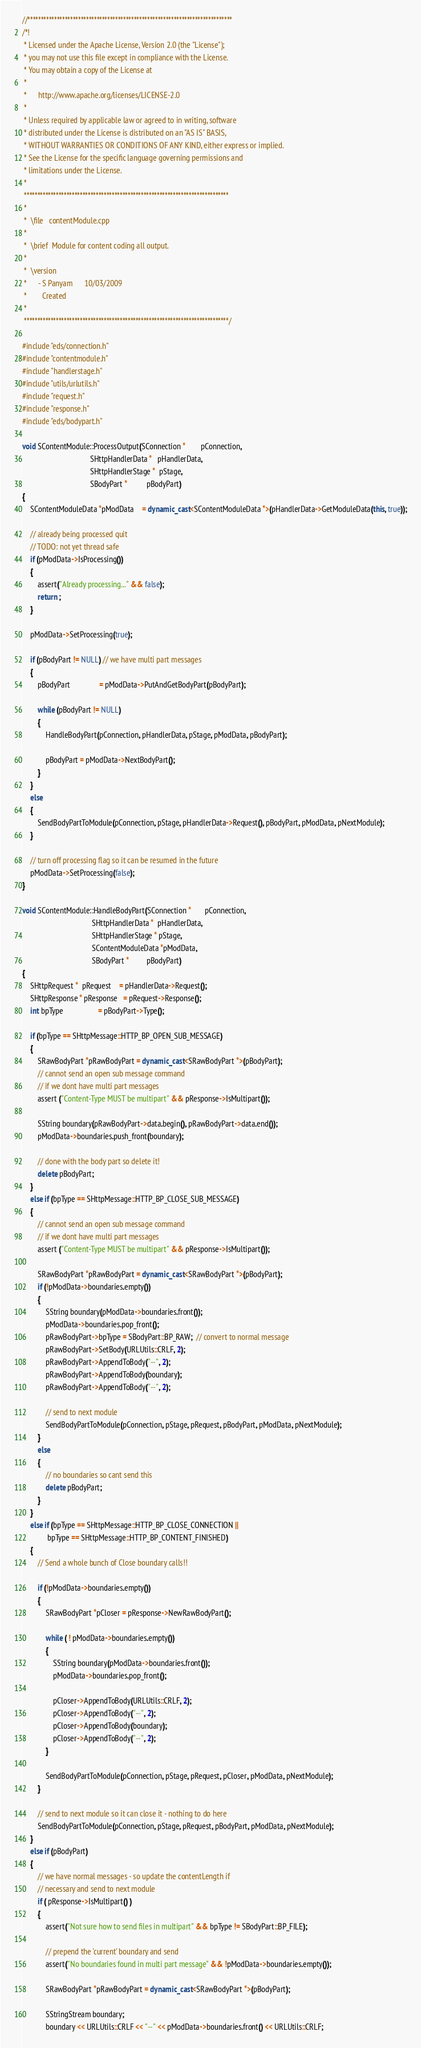Convert code to text. <code><loc_0><loc_0><loc_500><loc_500><_C++_>//*****************************************************************************
/*!
 * Licensed under the Apache License, Version 2.0 (the "License");
 * you may not use this file except in compliance with the License.
 * You may obtain a copy of the License at
 *
 *      http://www.apache.org/licenses/LICENSE-2.0
 *
 * Unless required by applicable law or agreed to in writing, software
 * distributed under the License is distributed on an "AS IS" BASIS,
 * WITHOUT WARRANTIES OR CONDITIONS OF ANY KIND, either express or implied.
 * See the License for the specific language governing permissions and
 * limitations under the License.
 *
 *****************************************************************************
 *
 *  \file   contentModule.cpp
 *
 *  \brief  Module for content coding all output.
 *
 *  \version
 *      - S Panyam      10/03/2009
 *        Created
 *
 *****************************************************************************/

#include "eds/connection.h"
#include "contentmodule.h"
#include "handlerstage.h"
#include "utils/urlutils.h"
#include "request.h"
#include "response.h"
#include "eds/bodypart.h"

void SContentModule::ProcessOutput(SConnection *        pConnection,
                                   SHttpHandlerData *   pHandlerData,
                                   SHttpHandlerStage *  pStage,
                                   SBodyPart *          pBodyPart)
{
    SContentModuleData *pModData    = dynamic_cast<SContentModuleData *>(pHandlerData->GetModuleData(this, true));

    // already being processed quit
    // TODO: not yet thread safe
    if (pModData->IsProcessing())
    {
        assert("Already processing..." && false);
        return ;
    }

    pModData->SetProcessing(true);

    if (pBodyPart != NULL) // we have multi part messages
    {
        pBodyPart               = pModData->PutAndGetBodyPart(pBodyPart);

        while (pBodyPart != NULL)
        {
            HandleBodyPart(pConnection, pHandlerData, pStage, pModData, pBodyPart);

            pBodyPart = pModData->NextBodyPart();
        }
    }
    else
    {
        SendBodyPartToModule(pConnection, pStage, pHandlerData->Request(), pBodyPart, pModData, pNextModule);
    }

    // turn off processing flag so it can be resumed in the future
    pModData->SetProcessing(false);
}

void SContentModule::HandleBodyPart(SConnection *       pConnection,
                                    SHttpHandlerData *  pHandlerData, 
                                    SHttpHandlerStage * pStage,
                                    SContentModuleData *pModData,
                                    SBodyPart *         pBodyPart)
{
    SHttpRequest *  pRequest    = pHandlerData->Request();
    SHttpResponse * pResponse   = pRequest->Response();
    int bpType                  = pBodyPart->Type();

    if (bpType == SHttpMessage::HTTP_BP_OPEN_SUB_MESSAGE)
    {
        SRawBodyPart *pRawBodyPart = dynamic_cast<SRawBodyPart *>(pBodyPart);
        // cannot send an open sub message command 
        // if we dont have multi part messages
        assert ("Content-Type MUST be multipart" && pResponse->IsMultipart());

        SString boundary(pRawBodyPart->data.begin(), pRawBodyPart->data.end());
        pModData->boundaries.push_front(boundary);

        // done with the body part so delete it!
        delete pBodyPart;
    }
    else if (bpType == SHttpMessage::HTTP_BP_CLOSE_SUB_MESSAGE)
    {
        // cannot send an open sub message command 
        // if we dont have multi part messages
        assert ("Content-Type MUST be multipart" && pResponse->IsMultipart());

        SRawBodyPart *pRawBodyPart = dynamic_cast<SRawBodyPart *>(pBodyPart);
        if (!pModData->boundaries.empty())
        {
            SString boundary(pModData->boundaries.front());
            pModData->boundaries.pop_front();
            pRawBodyPart->bpType = SBodyPart::BP_RAW;  // convert to normal message
            pRawBodyPart->SetBody(URLUtils::CRLF, 2);
            pRawBodyPart->AppendToBody("--", 2);
            pRawBodyPart->AppendToBody(boundary);
            pRawBodyPart->AppendToBody("--", 2);

            // send to next module
            SendBodyPartToModule(pConnection, pStage, pRequest, pBodyPart, pModData, pNextModule);
        }
        else
        {
            // no boundaries so cant send this
            delete pBodyPart;
        }
    }
    else if (bpType == SHttpMessage::HTTP_BP_CLOSE_CONNECTION ||
             bpType == SHttpMessage::HTTP_BP_CONTENT_FINISHED)
    {
        // Send a whole bunch of Close boundary calls!!

        if (!pModData->boundaries.empty())
        {
            SRawBodyPart *pCloser = pResponse->NewRawBodyPart();

            while ( ! pModData->boundaries.empty())
            {
                SString boundary(pModData->boundaries.front());
                pModData->boundaries.pop_front();

                pCloser->AppendToBody(URLUtils::CRLF, 2);
                pCloser->AppendToBody("--", 2);
                pCloser->AppendToBody(boundary);
                pCloser->AppendToBody("--", 2);
            }

            SendBodyPartToModule(pConnection, pStage, pRequest, pCloser, pModData, pNextModule);
        }

        // send to next module so it can close it - nothing to do here
        SendBodyPartToModule(pConnection, pStage, pRequest, pBodyPart, pModData, pNextModule);
    }
    else if (pBodyPart)
    {
        // we have normal messages - so update the contentLength if
        // necessary and send to next module
        if ( pResponse->IsMultipart() )
        {
            assert("Not sure how to send files in multipart" && bpType != SBodyPart::BP_FILE);

            // prepend the 'current' boundary and send
            assert("No boundaries found in multi part message" && !pModData->boundaries.empty());

            SRawBodyPart *pRawBodyPart = dynamic_cast<SRawBodyPart *>(pBodyPart);

            SStringStream boundary;
            boundary << URLUtils::CRLF << "--" << pModData->boundaries.front() << URLUtils::CRLF;</code> 